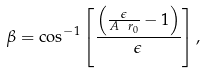Convert formula to latex. <formula><loc_0><loc_0><loc_500><loc_500>\beta = \cos ^ { - 1 } \left [ \frac { \left ( \frac { \epsilon } { A \ r _ { 0 } } - 1 \right ) } { \epsilon } \right ] ,</formula> 